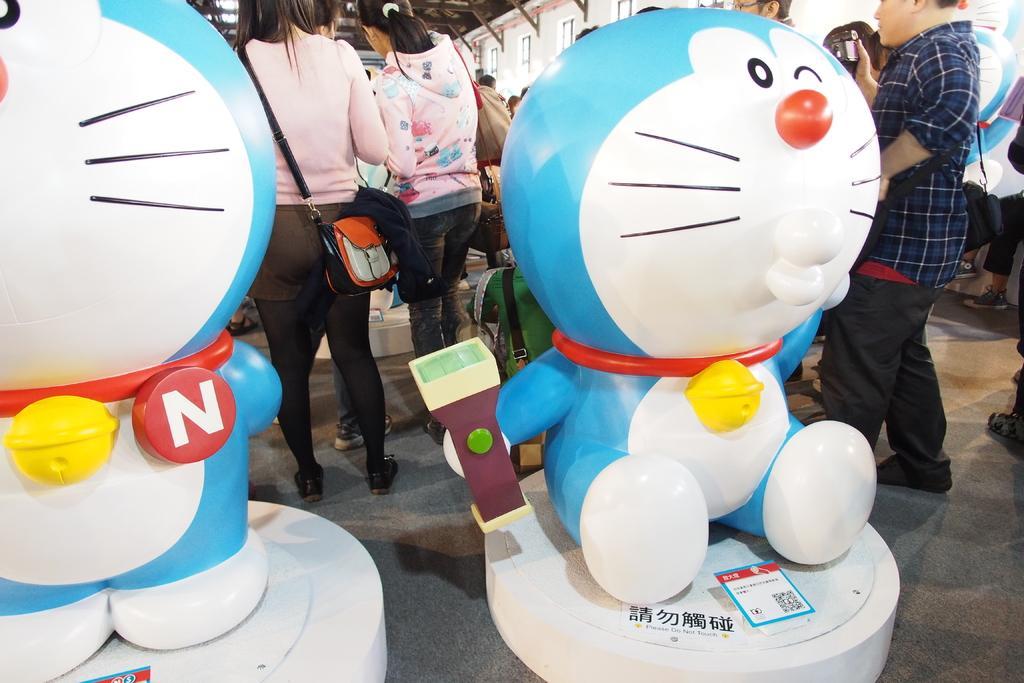Please provide a concise description of this image. In this image we can see toys and barcode. In the background we can see people wore bags. 